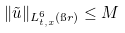<formula> <loc_0><loc_0><loc_500><loc_500>\| \tilde { u } \| _ { L ^ { 6 } _ { t , x } ( \i r ) } \leq M</formula> 